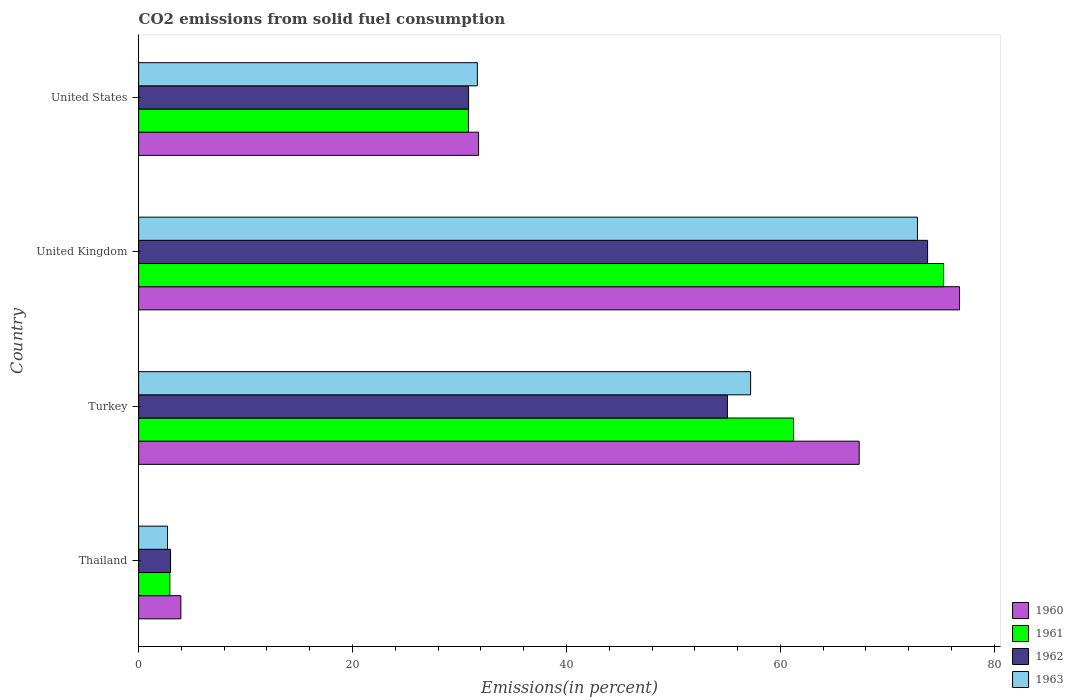How many groups of bars are there?
Make the answer very short. 4. How many bars are there on the 2nd tick from the bottom?
Make the answer very short. 4. What is the label of the 1st group of bars from the top?
Provide a short and direct response. United States. In how many cases, is the number of bars for a given country not equal to the number of legend labels?
Your answer should be compact. 0. What is the total CO2 emitted in 1960 in United States?
Provide a short and direct response. 31.78. Across all countries, what is the maximum total CO2 emitted in 1961?
Give a very brief answer. 75.26. Across all countries, what is the minimum total CO2 emitted in 1962?
Give a very brief answer. 2.99. In which country was the total CO2 emitted in 1963 minimum?
Your answer should be compact. Thailand. What is the total total CO2 emitted in 1962 in the graph?
Ensure brevity in your answer.  162.64. What is the difference between the total CO2 emitted in 1961 in Thailand and that in Turkey?
Your answer should be compact. -58.31. What is the difference between the total CO2 emitted in 1960 in United States and the total CO2 emitted in 1962 in Thailand?
Your answer should be very brief. 28.8. What is the average total CO2 emitted in 1961 per country?
Your response must be concise. 42.56. What is the difference between the total CO2 emitted in 1962 and total CO2 emitted in 1961 in United States?
Give a very brief answer. 0.02. In how many countries, is the total CO2 emitted in 1960 greater than 32 %?
Your answer should be compact. 2. What is the ratio of the total CO2 emitted in 1963 in Thailand to that in Turkey?
Offer a terse response. 0.05. What is the difference between the highest and the second highest total CO2 emitted in 1963?
Provide a short and direct response. 15.6. What is the difference between the highest and the lowest total CO2 emitted in 1963?
Provide a succinct answer. 70.11. In how many countries, is the total CO2 emitted in 1962 greater than the average total CO2 emitted in 1962 taken over all countries?
Give a very brief answer. 2. Is the sum of the total CO2 emitted in 1961 in Thailand and Turkey greater than the maximum total CO2 emitted in 1962 across all countries?
Your answer should be compact. No. What does the 3rd bar from the bottom in United Kingdom represents?
Keep it short and to the point. 1962. Is it the case that in every country, the sum of the total CO2 emitted in 1963 and total CO2 emitted in 1962 is greater than the total CO2 emitted in 1961?
Keep it short and to the point. Yes. How many countries are there in the graph?
Keep it short and to the point. 4. What is the difference between two consecutive major ticks on the X-axis?
Offer a very short reply. 20. Does the graph contain any zero values?
Offer a terse response. No. Where does the legend appear in the graph?
Keep it short and to the point. Bottom right. What is the title of the graph?
Offer a very short reply. CO2 emissions from solid fuel consumption. Does "2005" appear as one of the legend labels in the graph?
Provide a succinct answer. No. What is the label or title of the X-axis?
Provide a short and direct response. Emissions(in percent). What is the label or title of the Y-axis?
Your answer should be very brief. Country. What is the Emissions(in percent) in 1960 in Thailand?
Ensure brevity in your answer.  3.95. What is the Emissions(in percent) in 1961 in Thailand?
Make the answer very short. 2.92. What is the Emissions(in percent) in 1962 in Thailand?
Make the answer very short. 2.99. What is the Emissions(in percent) of 1963 in Thailand?
Offer a very short reply. 2.7. What is the Emissions(in percent) in 1960 in Turkey?
Give a very brief answer. 67.36. What is the Emissions(in percent) of 1961 in Turkey?
Offer a terse response. 61.22. What is the Emissions(in percent) of 1962 in Turkey?
Offer a very short reply. 55.04. What is the Emissions(in percent) in 1963 in Turkey?
Offer a very short reply. 57.21. What is the Emissions(in percent) of 1960 in United Kingdom?
Provide a short and direct response. 76.74. What is the Emissions(in percent) of 1961 in United Kingdom?
Give a very brief answer. 75.26. What is the Emissions(in percent) of 1962 in United Kingdom?
Offer a terse response. 73.76. What is the Emissions(in percent) in 1963 in United Kingdom?
Your response must be concise. 72.81. What is the Emissions(in percent) in 1960 in United States?
Provide a short and direct response. 31.78. What is the Emissions(in percent) in 1961 in United States?
Provide a short and direct response. 30.83. What is the Emissions(in percent) in 1962 in United States?
Provide a short and direct response. 30.85. What is the Emissions(in percent) of 1963 in United States?
Keep it short and to the point. 31.67. Across all countries, what is the maximum Emissions(in percent) in 1960?
Provide a succinct answer. 76.74. Across all countries, what is the maximum Emissions(in percent) in 1961?
Keep it short and to the point. 75.26. Across all countries, what is the maximum Emissions(in percent) of 1962?
Offer a terse response. 73.76. Across all countries, what is the maximum Emissions(in percent) in 1963?
Your answer should be compact. 72.81. Across all countries, what is the minimum Emissions(in percent) of 1960?
Offer a very short reply. 3.95. Across all countries, what is the minimum Emissions(in percent) in 1961?
Keep it short and to the point. 2.92. Across all countries, what is the minimum Emissions(in percent) of 1962?
Offer a terse response. 2.99. Across all countries, what is the minimum Emissions(in percent) in 1963?
Your response must be concise. 2.7. What is the total Emissions(in percent) in 1960 in the graph?
Offer a terse response. 179.84. What is the total Emissions(in percent) in 1961 in the graph?
Provide a succinct answer. 170.24. What is the total Emissions(in percent) in 1962 in the graph?
Offer a terse response. 162.64. What is the total Emissions(in percent) in 1963 in the graph?
Your response must be concise. 164.4. What is the difference between the Emissions(in percent) of 1960 in Thailand and that in Turkey?
Offer a very short reply. -63.42. What is the difference between the Emissions(in percent) of 1961 in Thailand and that in Turkey?
Offer a very short reply. -58.31. What is the difference between the Emissions(in percent) of 1962 in Thailand and that in Turkey?
Offer a terse response. -52.06. What is the difference between the Emissions(in percent) in 1963 in Thailand and that in Turkey?
Your response must be concise. -54.52. What is the difference between the Emissions(in percent) of 1960 in Thailand and that in United Kingdom?
Give a very brief answer. -72.8. What is the difference between the Emissions(in percent) of 1961 in Thailand and that in United Kingdom?
Keep it short and to the point. -72.34. What is the difference between the Emissions(in percent) in 1962 in Thailand and that in United Kingdom?
Make the answer very short. -70.77. What is the difference between the Emissions(in percent) of 1963 in Thailand and that in United Kingdom?
Ensure brevity in your answer.  -70.11. What is the difference between the Emissions(in percent) of 1960 in Thailand and that in United States?
Your answer should be compact. -27.83. What is the difference between the Emissions(in percent) in 1961 in Thailand and that in United States?
Provide a succinct answer. -27.92. What is the difference between the Emissions(in percent) of 1962 in Thailand and that in United States?
Provide a succinct answer. -27.86. What is the difference between the Emissions(in percent) in 1963 in Thailand and that in United States?
Make the answer very short. -28.97. What is the difference between the Emissions(in percent) of 1960 in Turkey and that in United Kingdom?
Your response must be concise. -9.38. What is the difference between the Emissions(in percent) in 1961 in Turkey and that in United Kingdom?
Your response must be concise. -14.04. What is the difference between the Emissions(in percent) in 1962 in Turkey and that in United Kingdom?
Give a very brief answer. -18.72. What is the difference between the Emissions(in percent) of 1963 in Turkey and that in United Kingdom?
Ensure brevity in your answer.  -15.6. What is the difference between the Emissions(in percent) in 1960 in Turkey and that in United States?
Your answer should be compact. 35.58. What is the difference between the Emissions(in percent) of 1961 in Turkey and that in United States?
Your response must be concise. 30.39. What is the difference between the Emissions(in percent) in 1962 in Turkey and that in United States?
Offer a very short reply. 24.19. What is the difference between the Emissions(in percent) of 1963 in Turkey and that in United States?
Make the answer very short. 25.55. What is the difference between the Emissions(in percent) of 1960 in United Kingdom and that in United States?
Ensure brevity in your answer.  44.96. What is the difference between the Emissions(in percent) of 1961 in United Kingdom and that in United States?
Keep it short and to the point. 44.43. What is the difference between the Emissions(in percent) of 1962 in United Kingdom and that in United States?
Ensure brevity in your answer.  42.91. What is the difference between the Emissions(in percent) of 1963 in United Kingdom and that in United States?
Give a very brief answer. 41.14. What is the difference between the Emissions(in percent) in 1960 in Thailand and the Emissions(in percent) in 1961 in Turkey?
Offer a terse response. -57.28. What is the difference between the Emissions(in percent) of 1960 in Thailand and the Emissions(in percent) of 1962 in Turkey?
Provide a succinct answer. -51.09. What is the difference between the Emissions(in percent) of 1960 in Thailand and the Emissions(in percent) of 1963 in Turkey?
Your answer should be compact. -53.27. What is the difference between the Emissions(in percent) in 1961 in Thailand and the Emissions(in percent) in 1962 in Turkey?
Your answer should be very brief. -52.13. What is the difference between the Emissions(in percent) in 1961 in Thailand and the Emissions(in percent) in 1963 in Turkey?
Your response must be concise. -54.3. What is the difference between the Emissions(in percent) in 1962 in Thailand and the Emissions(in percent) in 1963 in Turkey?
Your response must be concise. -54.23. What is the difference between the Emissions(in percent) in 1960 in Thailand and the Emissions(in percent) in 1961 in United Kingdom?
Offer a terse response. -71.31. What is the difference between the Emissions(in percent) of 1960 in Thailand and the Emissions(in percent) of 1962 in United Kingdom?
Provide a succinct answer. -69.81. What is the difference between the Emissions(in percent) of 1960 in Thailand and the Emissions(in percent) of 1963 in United Kingdom?
Ensure brevity in your answer.  -68.86. What is the difference between the Emissions(in percent) of 1961 in Thailand and the Emissions(in percent) of 1962 in United Kingdom?
Ensure brevity in your answer.  -70.84. What is the difference between the Emissions(in percent) in 1961 in Thailand and the Emissions(in percent) in 1963 in United Kingdom?
Give a very brief answer. -69.9. What is the difference between the Emissions(in percent) of 1962 in Thailand and the Emissions(in percent) of 1963 in United Kingdom?
Provide a short and direct response. -69.83. What is the difference between the Emissions(in percent) of 1960 in Thailand and the Emissions(in percent) of 1961 in United States?
Offer a terse response. -26.89. What is the difference between the Emissions(in percent) in 1960 in Thailand and the Emissions(in percent) in 1962 in United States?
Ensure brevity in your answer.  -26.9. What is the difference between the Emissions(in percent) in 1960 in Thailand and the Emissions(in percent) in 1963 in United States?
Your response must be concise. -27.72. What is the difference between the Emissions(in percent) in 1961 in Thailand and the Emissions(in percent) in 1962 in United States?
Your response must be concise. -27.93. What is the difference between the Emissions(in percent) of 1961 in Thailand and the Emissions(in percent) of 1963 in United States?
Ensure brevity in your answer.  -28.75. What is the difference between the Emissions(in percent) of 1962 in Thailand and the Emissions(in percent) of 1963 in United States?
Keep it short and to the point. -28.68. What is the difference between the Emissions(in percent) in 1960 in Turkey and the Emissions(in percent) in 1961 in United Kingdom?
Your response must be concise. -7.9. What is the difference between the Emissions(in percent) in 1960 in Turkey and the Emissions(in percent) in 1962 in United Kingdom?
Keep it short and to the point. -6.4. What is the difference between the Emissions(in percent) of 1960 in Turkey and the Emissions(in percent) of 1963 in United Kingdom?
Keep it short and to the point. -5.45. What is the difference between the Emissions(in percent) in 1961 in Turkey and the Emissions(in percent) in 1962 in United Kingdom?
Ensure brevity in your answer.  -12.54. What is the difference between the Emissions(in percent) of 1961 in Turkey and the Emissions(in percent) of 1963 in United Kingdom?
Give a very brief answer. -11.59. What is the difference between the Emissions(in percent) of 1962 in Turkey and the Emissions(in percent) of 1963 in United Kingdom?
Your response must be concise. -17.77. What is the difference between the Emissions(in percent) of 1960 in Turkey and the Emissions(in percent) of 1961 in United States?
Provide a short and direct response. 36.53. What is the difference between the Emissions(in percent) in 1960 in Turkey and the Emissions(in percent) in 1962 in United States?
Make the answer very short. 36.51. What is the difference between the Emissions(in percent) of 1960 in Turkey and the Emissions(in percent) of 1963 in United States?
Keep it short and to the point. 35.7. What is the difference between the Emissions(in percent) in 1961 in Turkey and the Emissions(in percent) in 1962 in United States?
Your answer should be very brief. 30.37. What is the difference between the Emissions(in percent) in 1961 in Turkey and the Emissions(in percent) in 1963 in United States?
Your answer should be compact. 29.56. What is the difference between the Emissions(in percent) in 1962 in Turkey and the Emissions(in percent) in 1963 in United States?
Offer a terse response. 23.37. What is the difference between the Emissions(in percent) of 1960 in United Kingdom and the Emissions(in percent) of 1961 in United States?
Your answer should be compact. 45.91. What is the difference between the Emissions(in percent) in 1960 in United Kingdom and the Emissions(in percent) in 1962 in United States?
Keep it short and to the point. 45.89. What is the difference between the Emissions(in percent) of 1960 in United Kingdom and the Emissions(in percent) of 1963 in United States?
Offer a very short reply. 45.08. What is the difference between the Emissions(in percent) of 1961 in United Kingdom and the Emissions(in percent) of 1962 in United States?
Keep it short and to the point. 44.41. What is the difference between the Emissions(in percent) of 1961 in United Kingdom and the Emissions(in percent) of 1963 in United States?
Your answer should be very brief. 43.59. What is the difference between the Emissions(in percent) in 1962 in United Kingdom and the Emissions(in percent) in 1963 in United States?
Make the answer very short. 42.09. What is the average Emissions(in percent) in 1960 per country?
Ensure brevity in your answer.  44.96. What is the average Emissions(in percent) in 1961 per country?
Your answer should be very brief. 42.56. What is the average Emissions(in percent) in 1962 per country?
Offer a very short reply. 40.66. What is the average Emissions(in percent) in 1963 per country?
Your answer should be very brief. 41.1. What is the difference between the Emissions(in percent) in 1960 and Emissions(in percent) in 1961 in Thailand?
Provide a short and direct response. 1.03. What is the difference between the Emissions(in percent) of 1960 and Emissions(in percent) of 1962 in Thailand?
Provide a succinct answer. 0.96. What is the difference between the Emissions(in percent) in 1960 and Emissions(in percent) in 1963 in Thailand?
Make the answer very short. 1.25. What is the difference between the Emissions(in percent) in 1961 and Emissions(in percent) in 1962 in Thailand?
Offer a very short reply. -0.07. What is the difference between the Emissions(in percent) in 1961 and Emissions(in percent) in 1963 in Thailand?
Keep it short and to the point. 0.22. What is the difference between the Emissions(in percent) in 1962 and Emissions(in percent) in 1963 in Thailand?
Keep it short and to the point. 0.29. What is the difference between the Emissions(in percent) of 1960 and Emissions(in percent) of 1961 in Turkey?
Your response must be concise. 6.14. What is the difference between the Emissions(in percent) in 1960 and Emissions(in percent) in 1962 in Turkey?
Provide a short and direct response. 12.32. What is the difference between the Emissions(in percent) of 1960 and Emissions(in percent) of 1963 in Turkey?
Offer a terse response. 10.15. What is the difference between the Emissions(in percent) in 1961 and Emissions(in percent) in 1962 in Turkey?
Offer a very short reply. 6.18. What is the difference between the Emissions(in percent) of 1961 and Emissions(in percent) of 1963 in Turkey?
Offer a very short reply. 4.01. What is the difference between the Emissions(in percent) of 1962 and Emissions(in percent) of 1963 in Turkey?
Your response must be concise. -2.17. What is the difference between the Emissions(in percent) in 1960 and Emissions(in percent) in 1961 in United Kingdom?
Give a very brief answer. 1.48. What is the difference between the Emissions(in percent) of 1960 and Emissions(in percent) of 1962 in United Kingdom?
Keep it short and to the point. 2.98. What is the difference between the Emissions(in percent) in 1960 and Emissions(in percent) in 1963 in United Kingdom?
Offer a very short reply. 3.93. What is the difference between the Emissions(in percent) of 1961 and Emissions(in percent) of 1962 in United Kingdom?
Provide a short and direct response. 1.5. What is the difference between the Emissions(in percent) of 1961 and Emissions(in percent) of 1963 in United Kingdom?
Your answer should be compact. 2.45. What is the difference between the Emissions(in percent) in 1962 and Emissions(in percent) in 1963 in United Kingdom?
Keep it short and to the point. 0.95. What is the difference between the Emissions(in percent) of 1960 and Emissions(in percent) of 1961 in United States?
Your answer should be very brief. 0.95. What is the difference between the Emissions(in percent) in 1960 and Emissions(in percent) in 1962 in United States?
Provide a succinct answer. 0.93. What is the difference between the Emissions(in percent) in 1960 and Emissions(in percent) in 1963 in United States?
Give a very brief answer. 0.11. What is the difference between the Emissions(in percent) of 1961 and Emissions(in percent) of 1962 in United States?
Your answer should be very brief. -0.02. What is the difference between the Emissions(in percent) in 1961 and Emissions(in percent) in 1963 in United States?
Provide a short and direct response. -0.83. What is the difference between the Emissions(in percent) of 1962 and Emissions(in percent) of 1963 in United States?
Give a very brief answer. -0.82. What is the ratio of the Emissions(in percent) of 1960 in Thailand to that in Turkey?
Offer a very short reply. 0.06. What is the ratio of the Emissions(in percent) in 1961 in Thailand to that in Turkey?
Make the answer very short. 0.05. What is the ratio of the Emissions(in percent) of 1962 in Thailand to that in Turkey?
Provide a succinct answer. 0.05. What is the ratio of the Emissions(in percent) in 1963 in Thailand to that in Turkey?
Offer a very short reply. 0.05. What is the ratio of the Emissions(in percent) of 1960 in Thailand to that in United Kingdom?
Make the answer very short. 0.05. What is the ratio of the Emissions(in percent) of 1961 in Thailand to that in United Kingdom?
Make the answer very short. 0.04. What is the ratio of the Emissions(in percent) of 1962 in Thailand to that in United Kingdom?
Your answer should be compact. 0.04. What is the ratio of the Emissions(in percent) of 1963 in Thailand to that in United Kingdom?
Provide a succinct answer. 0.04. What is the ratio of the Emissions(in percent) in 1960 in Thailand to that in United States?
Give a very brief answer. 0.12. What is the ratio of the Emissions(in percent) in 1961 in Thailand to that in United States?
Offer a very short reply. 0.09. What is the ratio of the Emissions(in percent) of 1962 in Thailand to that in United States?
Ensure brevity in your answer.  0.1. What is the ratio of the Emissions(in percent) of 1963 in Thailand to that in United States?
Provide a short and direct response. 0.09. What is the ratio of the Emissions(in percent) in 1960 in Turkey to that in United Kingdom?
Your response must be concise. 0.88. What is the ratio of the Emissions(in percent) of 1961 in Turkey to that in United Kingdom?
Offer a terse response. 0.81. What is the ratio of the Emissions(in percent) in 1962 in Turkey to that in United Kingdom?
Provide a succinct answer. 0.75. What is the ratio of the Emissions(in percent) in 1963 in Turkey to that in United Kingdom?
Ensure brevity in your answer.  0.79. What is the ratio of the Emissions(in percent) in 1960 in Turkey to that in United States?
Offer a very short reply. 2.12. What is the ratio of the Emissions(in percent) of 1961 in Turkey to that in United States?
Make the answer very short. 1.99. What is the ratio of the Emissions(in percent) of 1962 in Turkey to that in United States?
Your response must be concise. 1.78. What is the ratio of the Emissions(in percent) of 1963 in Turkey to that in United States?
Give a very brief answer. 1.81. What is the ratio of the Emissions(in percent) in 1960 in United Kingdom to that in United States?
Offer a terse response. 2.41. What is the ratio of the Emissions(in percent) of 1961 in United Kingdom to that in United States?
Make the answer very short. 2.44. What is the ratio of the Emissions(in percent) of 1962 in United Kingdom to that in United States?
Make the answer very short. 2.39. What is the ratio of the Emissions(in percent) in 1963 in United Kingdom to that in United States?
Make the answer very short. 2.3. What is the difference between the highest and the second highest Emissions(in percent) of 1960?
Offer a terse response. 9.38. What is the difference between the highest and the second highest Emissions(in percent) in 1961?
Your answer should be very brief. 14.04. What is the difference between the highest and the second highest Emissions(in percent) in 1962?
Make the answer very short. 18.72. What is the difference between the highest and the second highest Emissions(in percent) in 1963?
Your answer should be compact. 15.6. What is the difference between the highest and the lowest Emissions(in percent) in 1960?
Ensure brevity in your answer.  72.8. What is the difference between the highest and the lowest Emissions(in percent) of 1961?
Provide a short and direct response. 72.34. What is the difference between the highest and the lowest Emissions(in percent) in 1962?
Offer a very short reply. 70.77. What is the difference between the highest and the lowest Emissions(in percent) in 1963?
Ensure brevity in your answer.  70.11. 